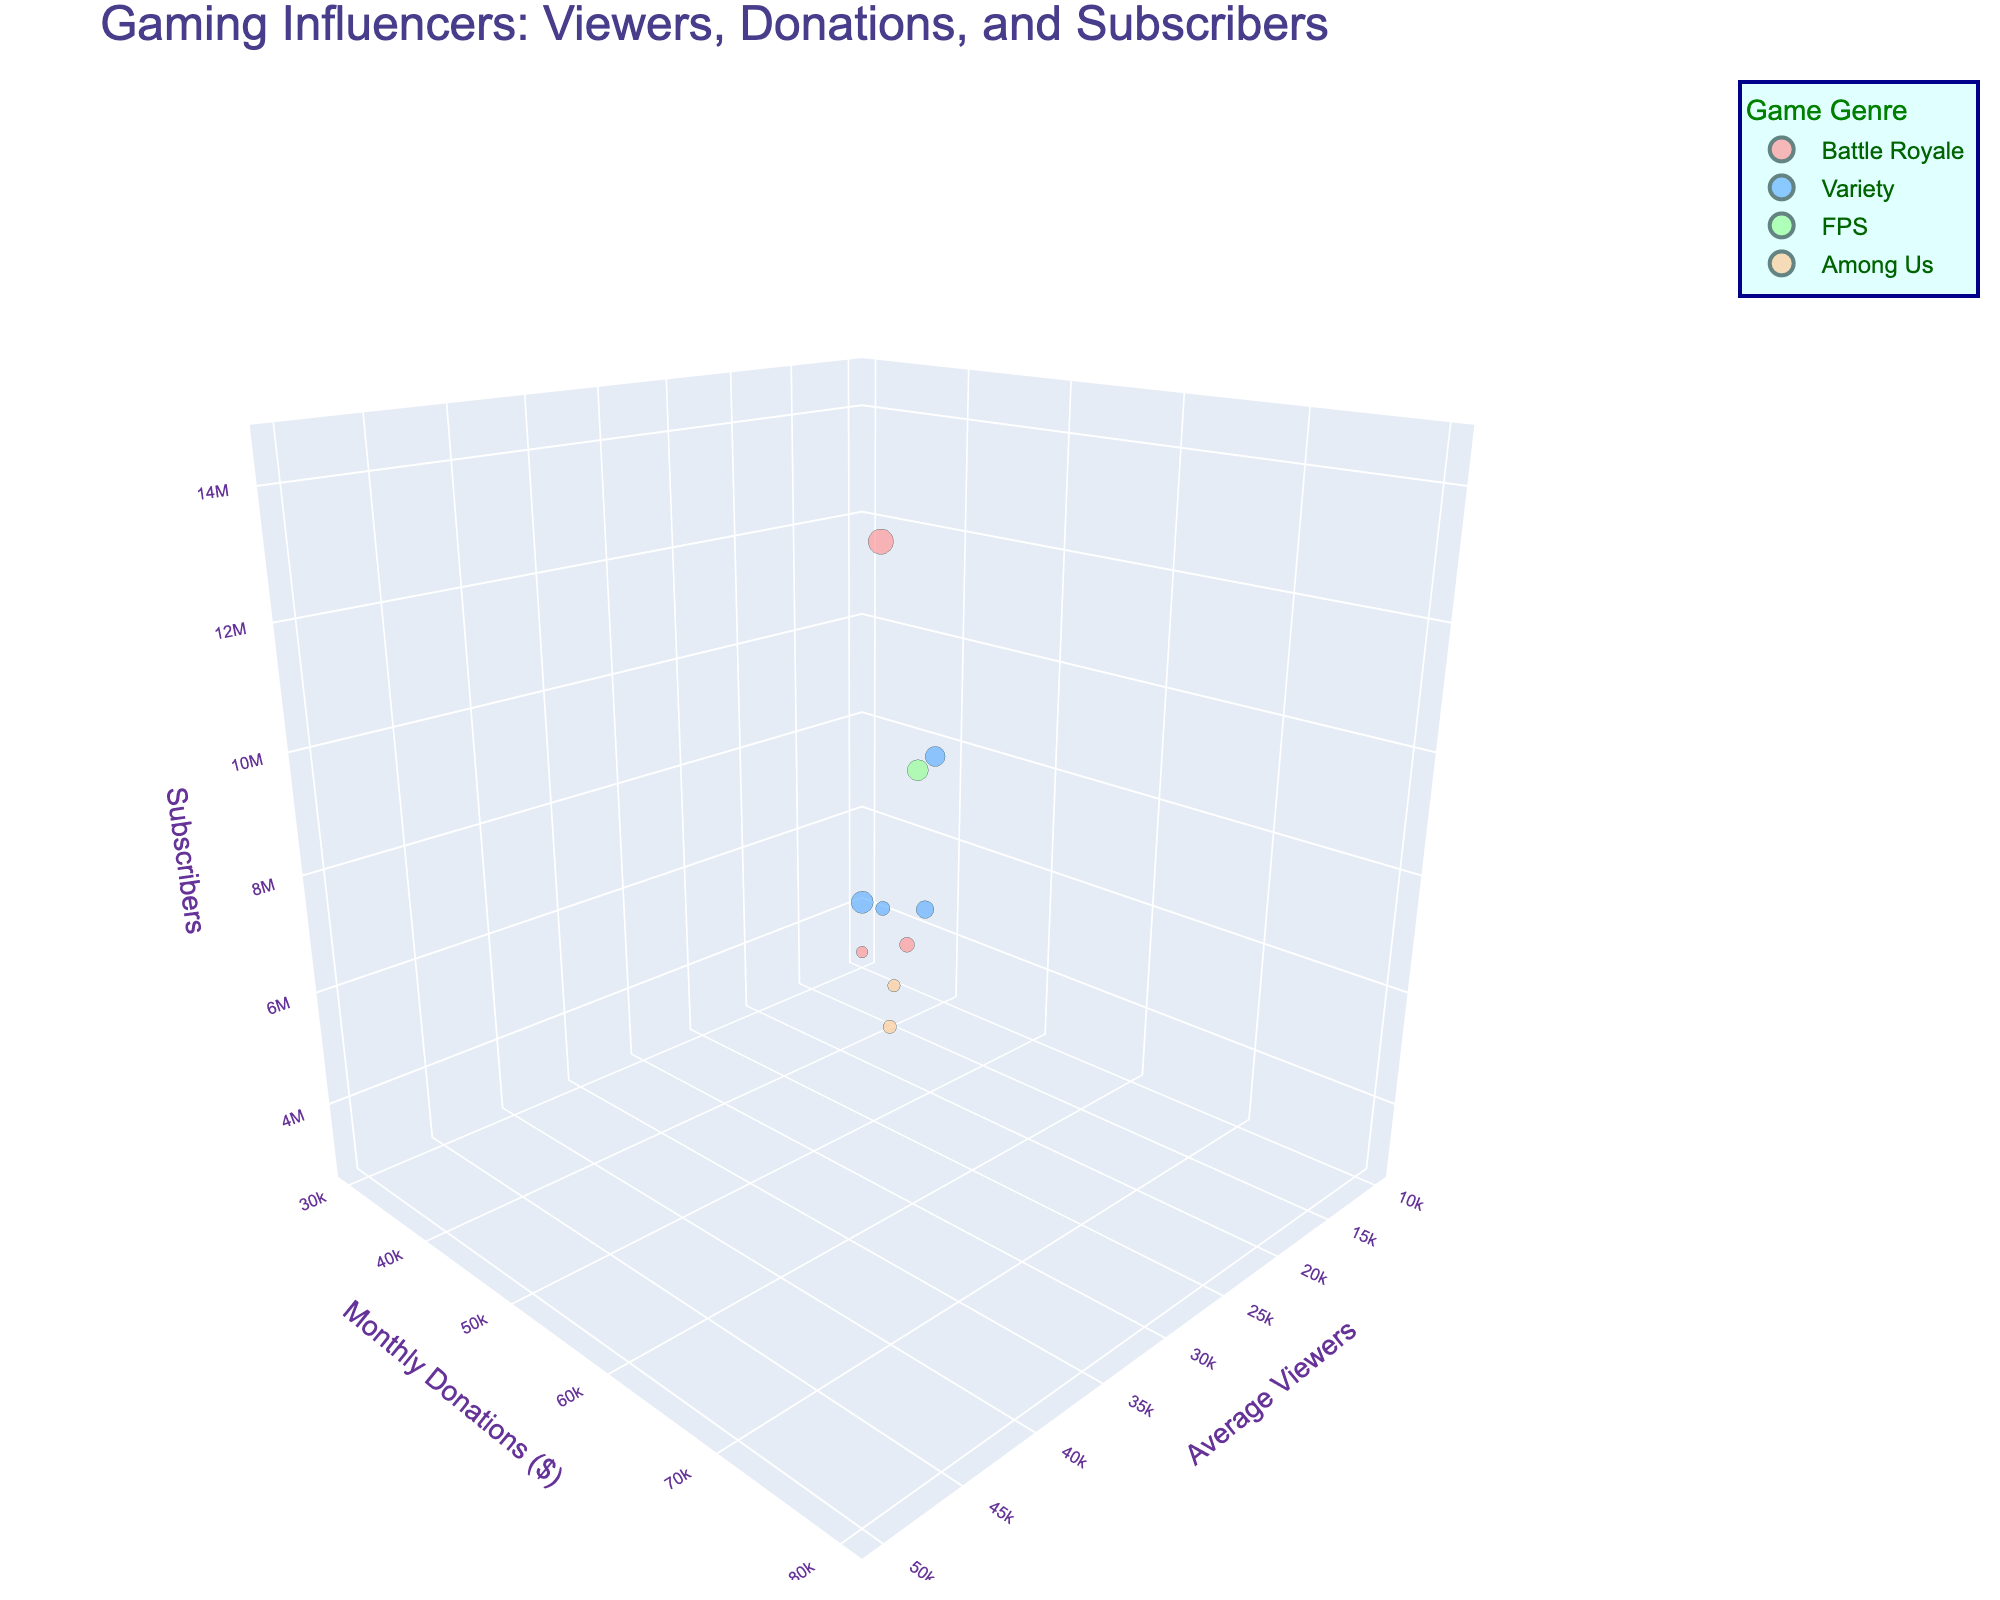What is the title of the chart? The title is displayed at the top of the chart. It provides an overview of what the chart is illustrating.
Answer: Gaming Influencers: Viewers, Donations, and Subscribers How many gaming influencers are displayed in the chart? Each bubble in the 3D chart represents one gaming influencer. Count the number of bubbles.
Answer: 10 Which influencer has the highest average viewers? Look at the x-axis (Average Viewers) and find the bubble that is furthest to the right. The hover name will identify the influencer.
Answer: xQc Which game genre has the most monthly donations overall? Identify the color of each game genre and sum the values on the y-axis (Monthly Donations) for each genre. The highest total will indicate which game genre has the most donations.
Answer: Variety What is the exact monthly donation amount for the influencer with the highest subscribers? Identify the influencer with the largest bubble (Subscribers) and then look at their position on the y-axis. Use the hover name to confirm the influencer.
Answer: $75,000 Which influencer has the least subscribers and how many do they have? Find the smallest bubble, which represents the fewest subscribers, and then use the hover name to identify the influencer.
Answer: Myth, 3,000,000 Compare the monthly donations of Ninja and Shroud. Who receives more and by how much? Locate the bubbles corresponding to Ninja and Shroud. Note their positions on the y-axis and subtract the smaller value from the larger value to find the difference.
Answer: Ninja, by $15,000 What is the average number of subscribers for influencers in the 'Variety' genre? Identify all influencers with the same color representing 'Variety'. Sum their subscriber counts and divide by the number of influencers in that genre.
Answer: 7,600,000 Which game genre is associated with the influencer having both the highest average viewers and the highest monthly donations? Find the bubble furthest to the right and at the top front. Check the color of the bubble and match it with the game genre represented by that color.
Answer: Battle Royale Which influencer has more average viewers: Tfue or Sykkuno? Locate the bubbles corresponding to Tfue and Sykkuno. Compare their positions on the x-axis (Average Viewers) to see which one is further to the right.
Answer: Sykkuno 